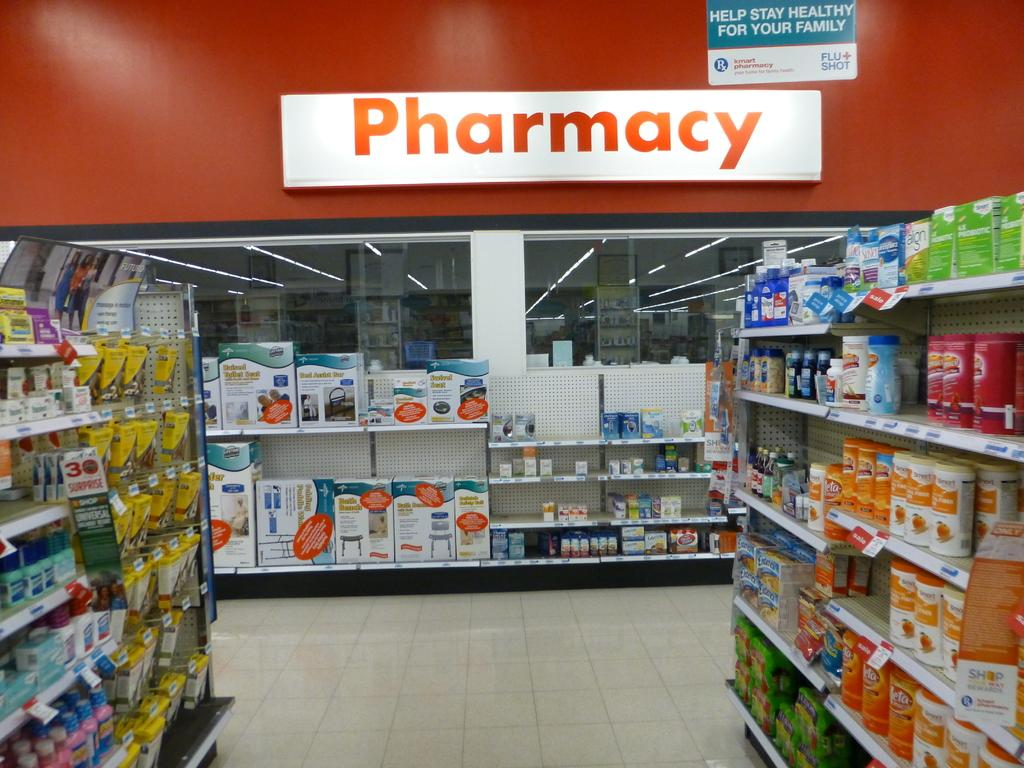<image>
Present a compact description of the photo's key features. medicine isle of store with pharmacy in the back and sign overhead that states help stay healthy for your family 